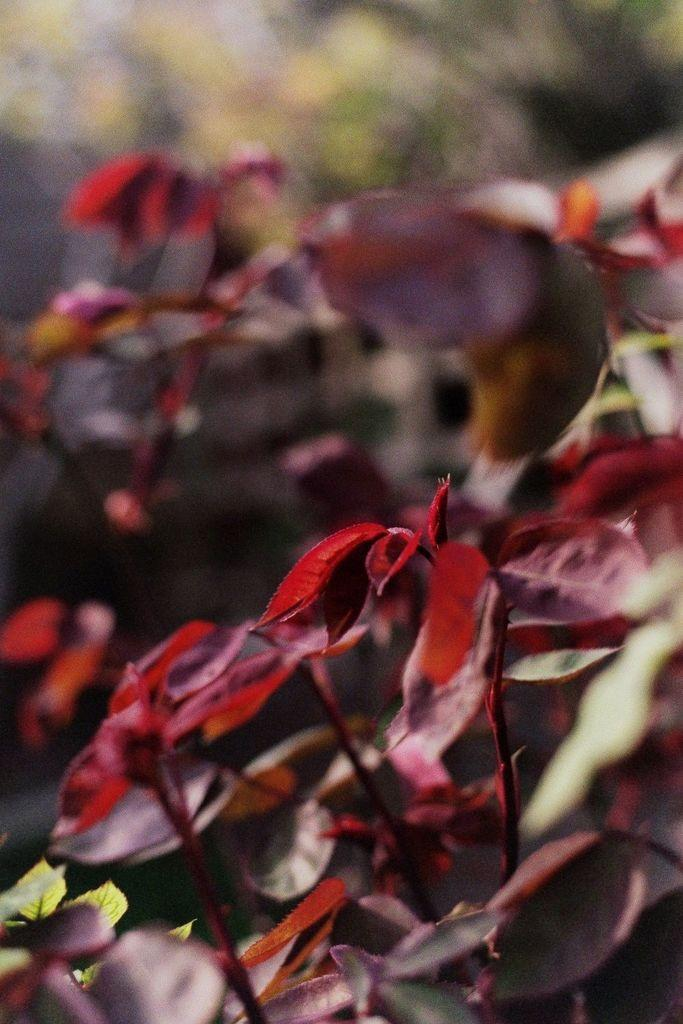What type of living organisms can be seen in the image? Plants can be seen in the image. What colors are present on the plants in the image? The plants have green, red, and maroon colors. What is the condition of the background in the image? The background of the image is blurry. What type of vegetation can be seen in the background of the image? Trees are visible in the background of the image. How many buns are stacked on top of each other in the image? There are no buns present in the image. What type of cherries can be seen hanging from the trees in the image? There are no cherries visible in the image; only trees are present in the background. 